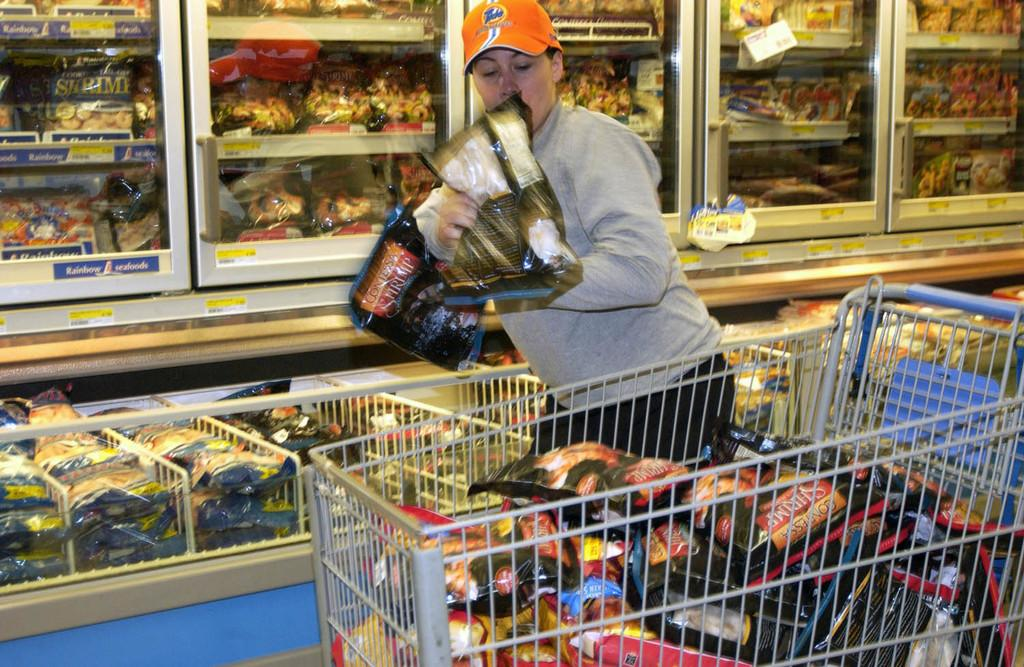<image>
Present a compact description of the photo's key features. A woman grabs a bag of Contessa shrimp and tosses it into a shopping cart. 